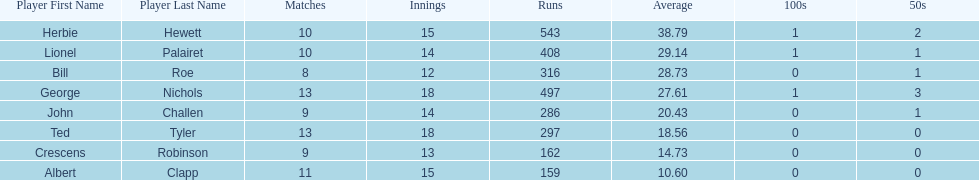How many innings did bill and ted have in total? 30. 